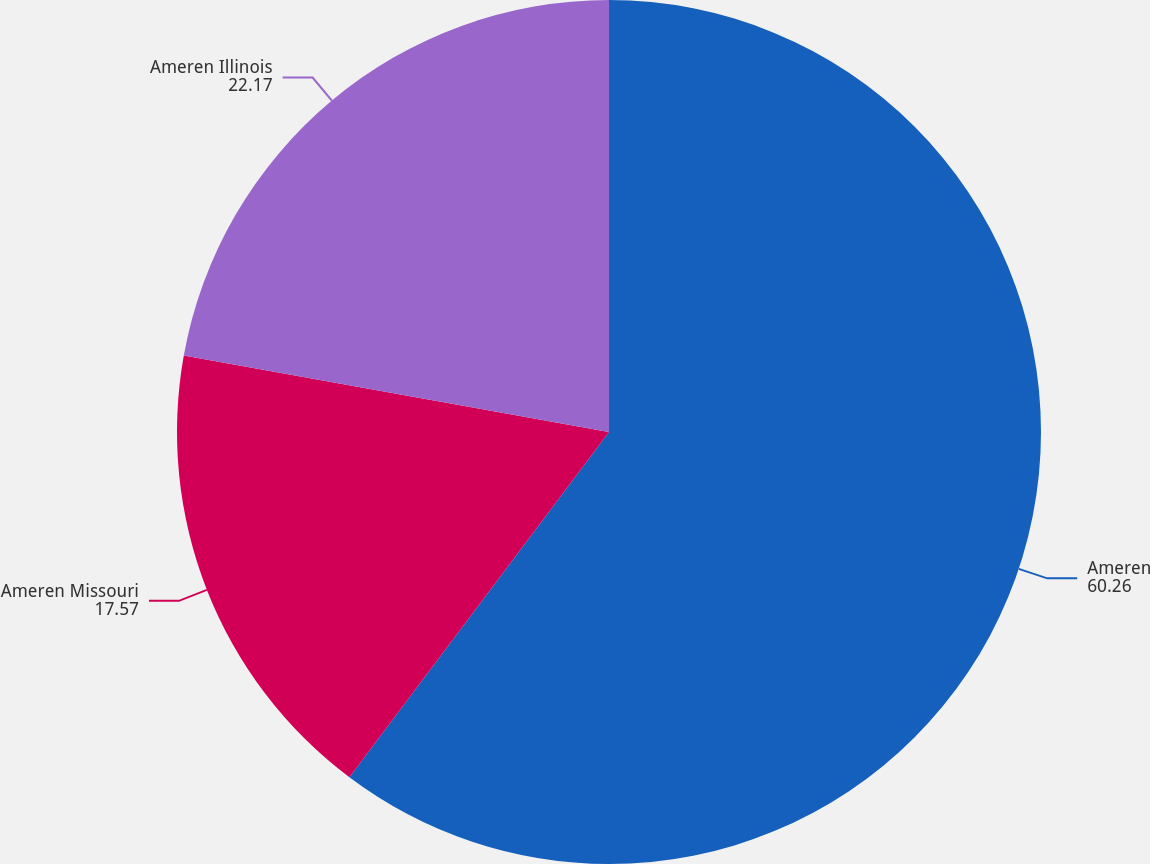Convert chart. <chart><loc_0><loc_0><loc_500><loc_500><pie_chart><fcel>Ameren<fcel>Ameren Missouri<fcel>Ameren Illinois<nl><fcel>60.26%<fcel>17.57%<fcel>22.17%<nl></chart> 